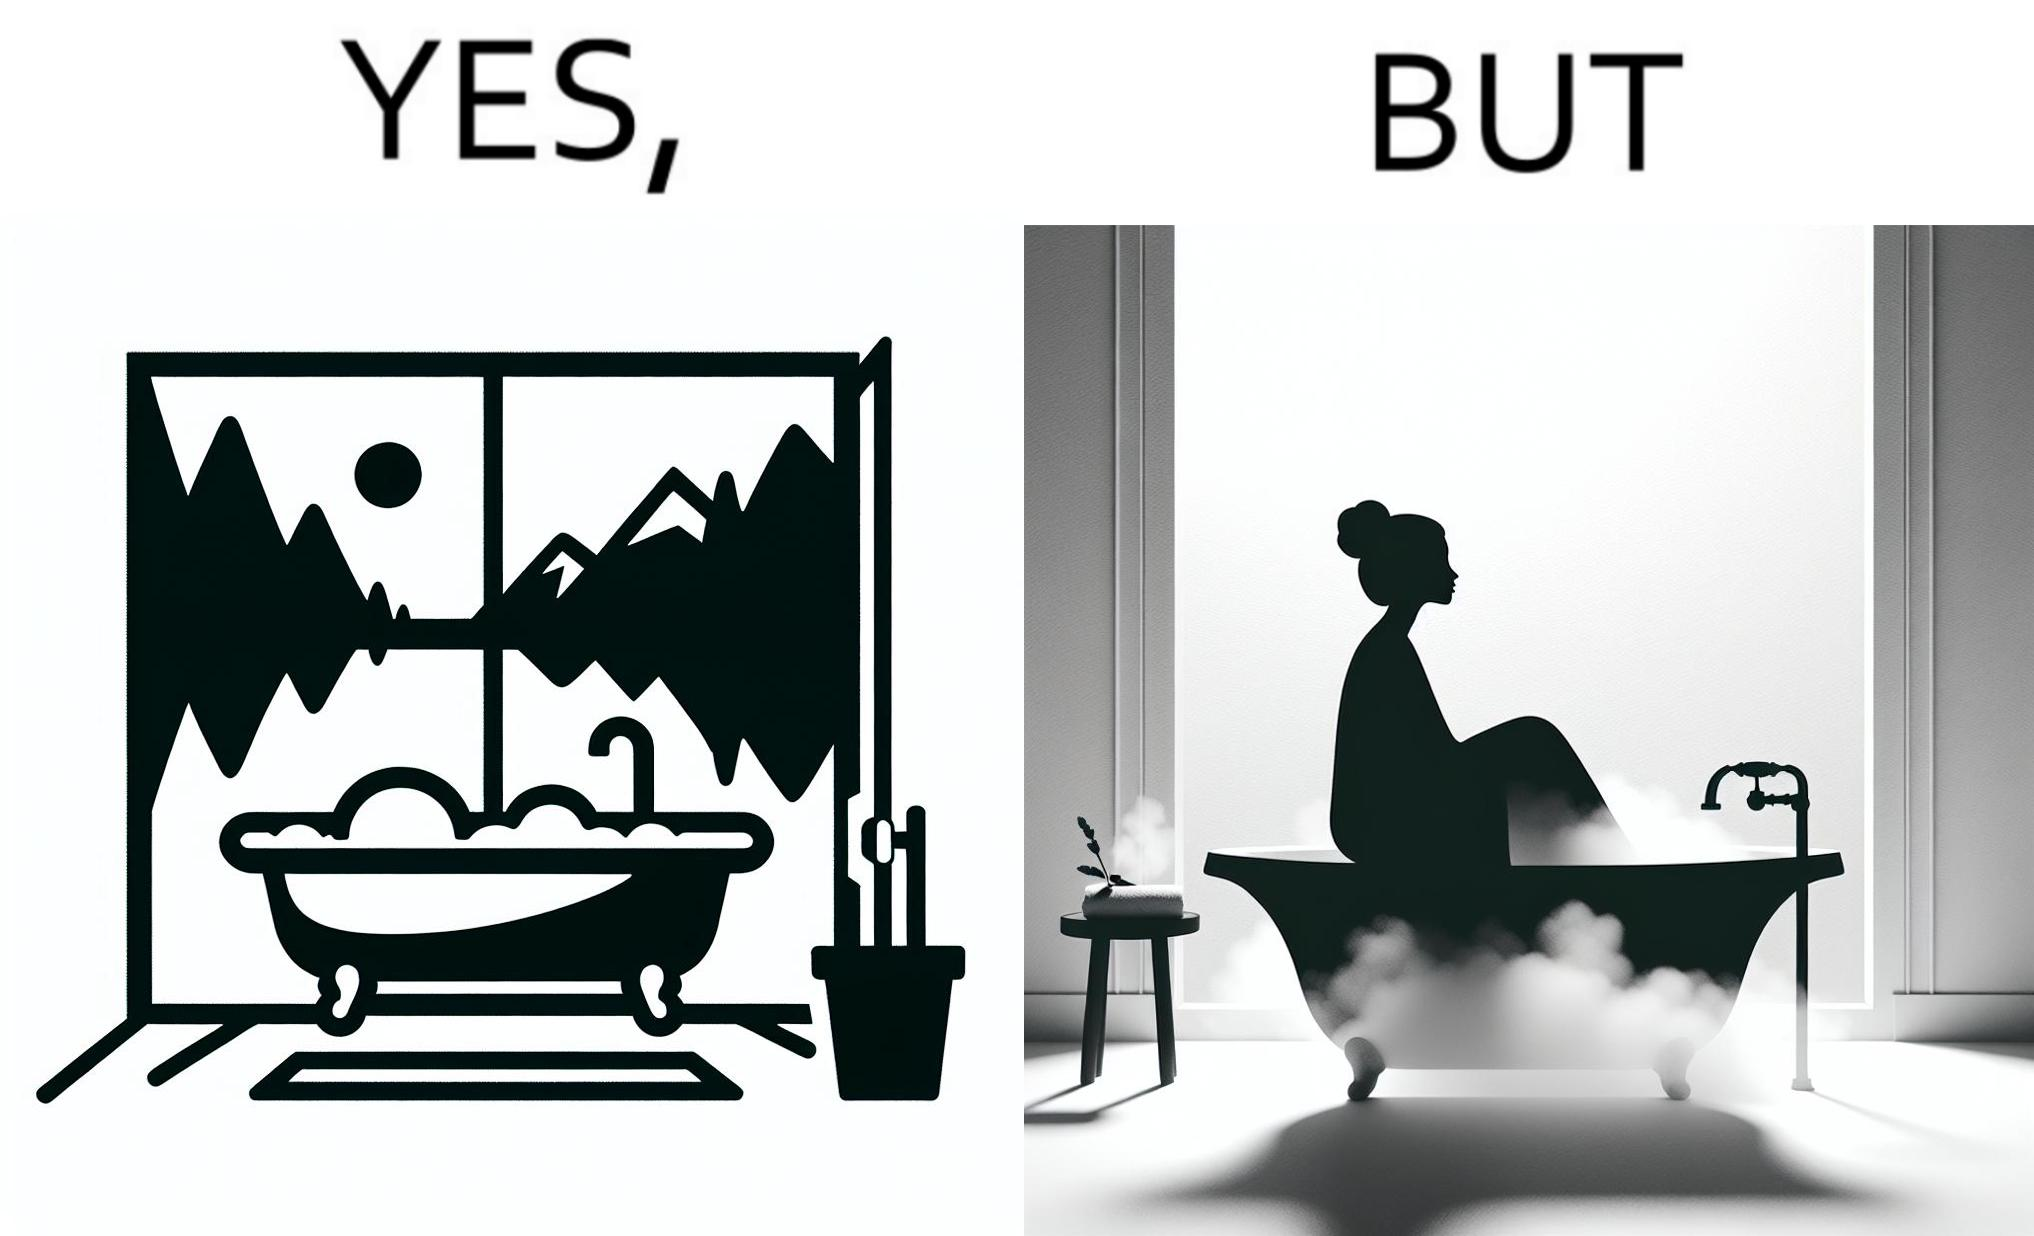Why is this image considered satirical? The image is ironical, as a bathtub near a window having a very scenic view, becomes misty when someone is bathing, thus making the scenic view blurry. 